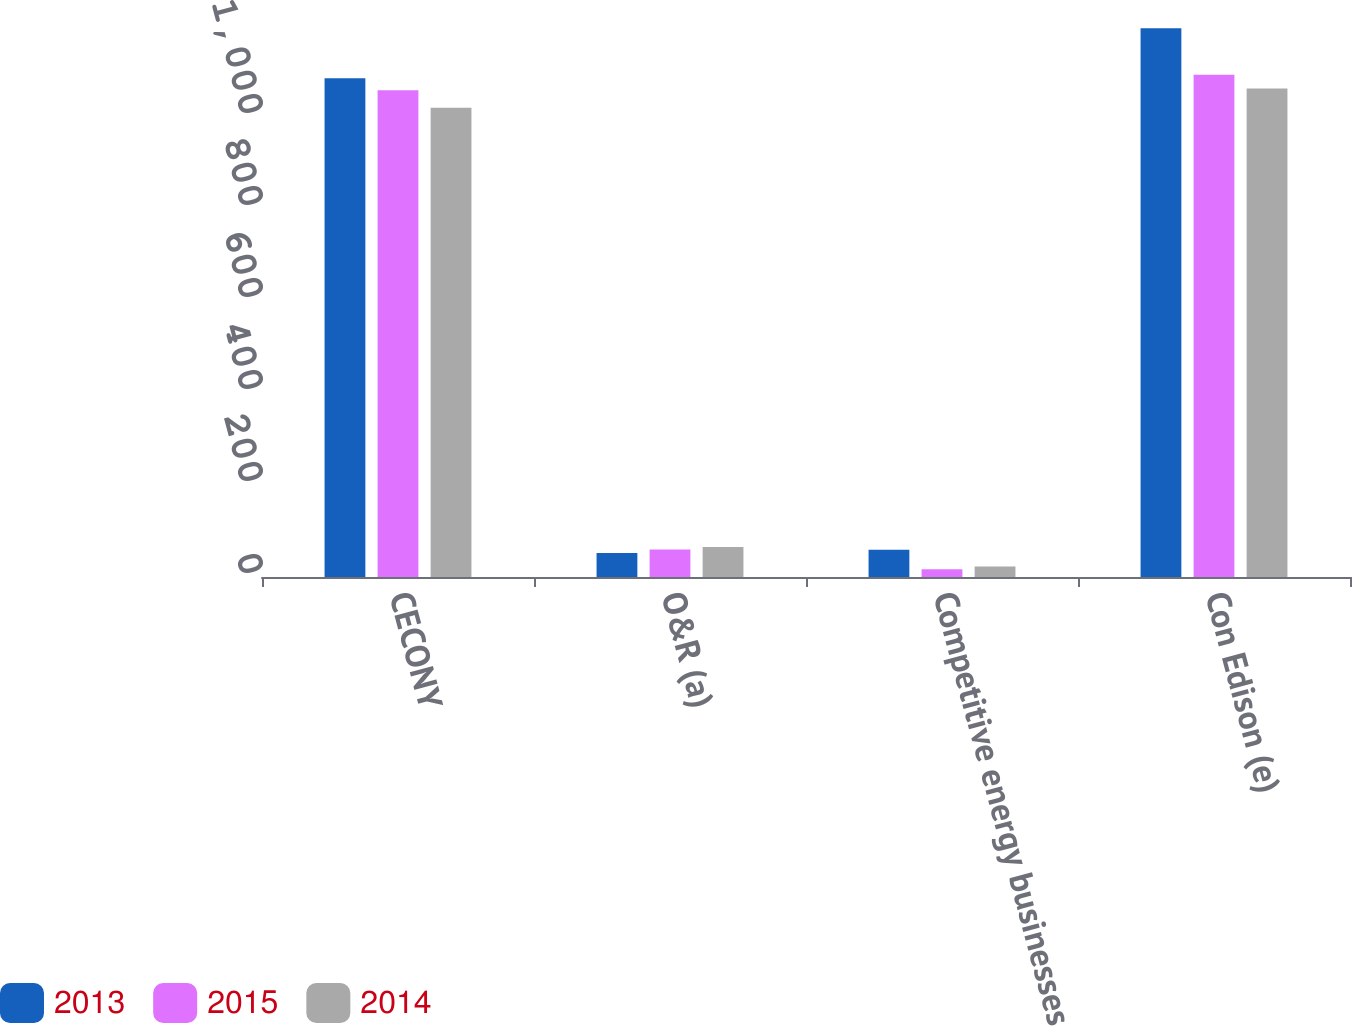Convert chart to OTSL. <chart><loc_0><loc_0><loc_500><loc_500><stacked_bar_chart><ecel><fcel>CECONY<fcel>O&R (a)<fcel>Competitive energy businesses<fcel>Con Edison (e)<nl><fcel>2013<fcel>1084<fcel>52<fcel>59<fcel>1193<nl><fcel>2015<fcel>1058<fcel>60<fcel>17<fcel>1092<nl><fcel>2014<fcel>1020<fcel>65<fcel>23<fcel>1062<nl></chart> 